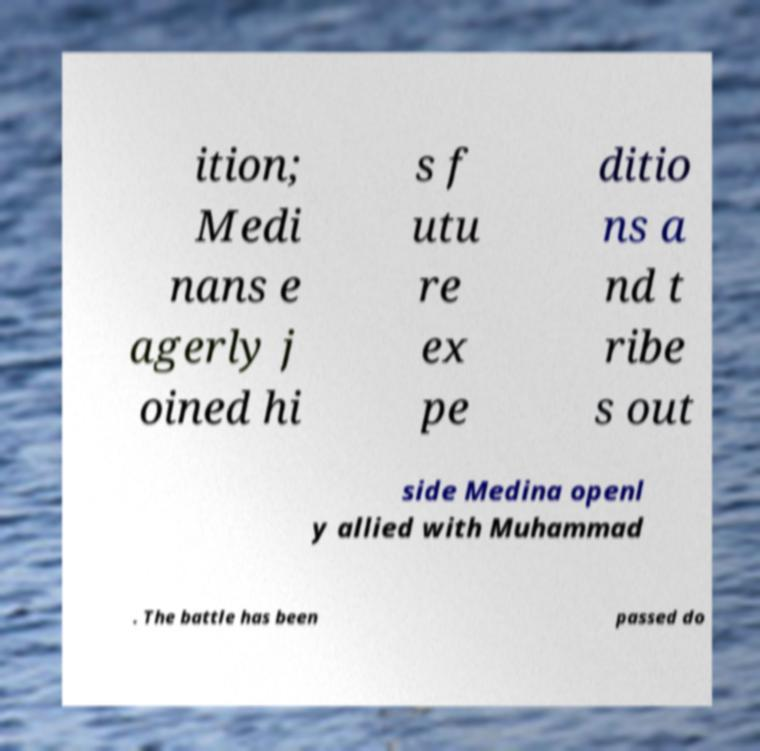Could you assist in decoding the text presented in this image and type it out clearly? ition; Medi nans e agerly j oined hi s f utu re ex pe ditio ns a nd t ribe s out side Medina openl y allied with Muhammad . The battle has been passed do 